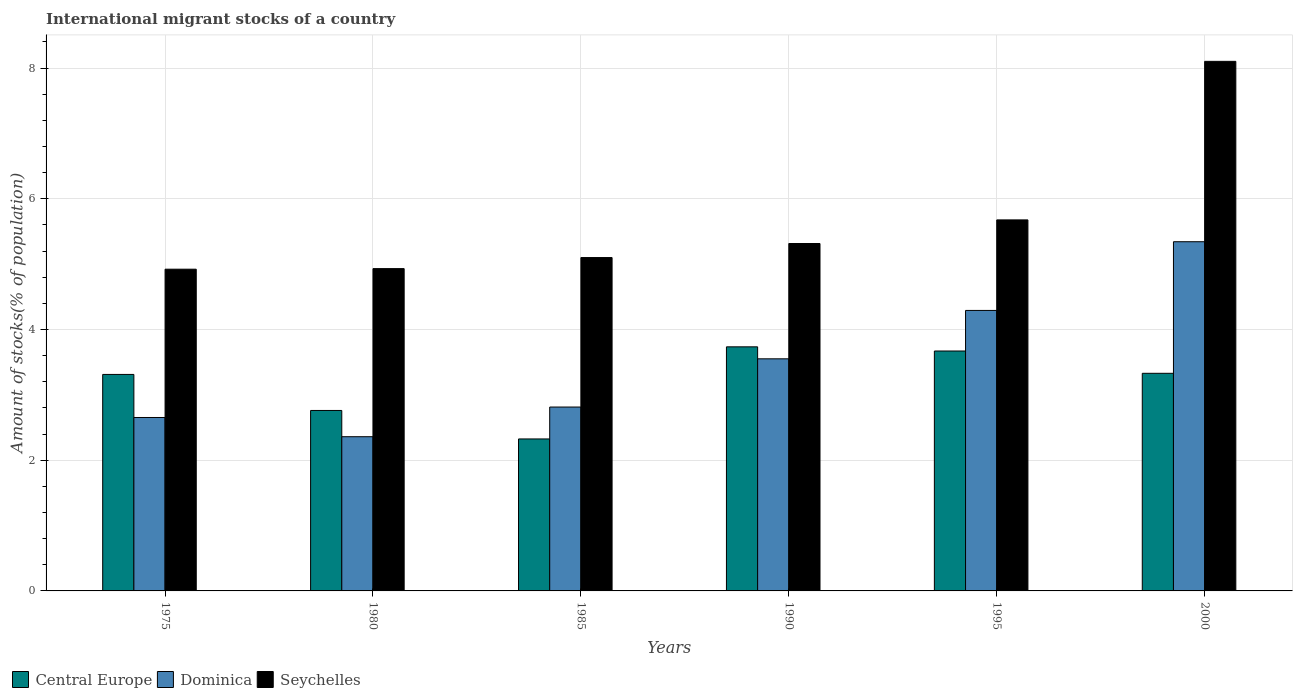Are the number of bars per tick equal to the number of legend labels?
Ensure brevity in your answer.  Yes. Are the number of bars on each tick of the X-axis equal?
Your response must be concise. Yes. How many bars are there on the 5th tick from the left?
Offer a terse response. 3. What is the label of the 4th group of bars from the left?
Provide a short and direct response. 1990. What is the amount of stocks in in Central Europe in 1995?
Your response must be concise. 3.67. Across all years, what is the maximum amount of stocks in in Seychelles?
Your answer should be very brief. 8.1. Across all years, what is the minimum amount of stocks in in Central Europe?
Your response must be concise. 2.33. In which year was the amount of stocks in in Seychelles maximum?
Make the answer very short. 2000. What is the total amount of stocks in in Seychelles in the graph?
Your answer should be compact. 34.05. What is the difference between the amount of stocks in in Dominica in 1985 and that in 1995?
Your answer should be compact. -1.48. What is the difference between the amount of stocks in in Central Europe in 2000 and the amount of stocks in in Dominica in 1980?
Provide a short and direct response. 0.97. What is the average amount of stocks in in Central Europe per year?
Provide a succinct answer. 3.19. In the year 1980, what is the difference between the amount of stocks in in Central Europe and amount of stocks in in Dominica?
Keep it short and to the point. 0.4. In how many years, is the amount of stocks in in Dominica greater than 7.2 %?
Provide a succinct answer. 0. What is the ratio of the amount of stocks in in Dominica in 1995 to that in 2000?
Ensure brevity in your answer.  0.8. Is the amount of stocks in in Seychelles in 1975 less than that in 1985?
Offer a very short reply. Yes. Is the difference between the amount of stocks in in Central Europe in 1995 and 2000 greater than the difference between the amount of stocks in in Dominica in 1995 and 2000?
Make the answer very short. Yes. What is the difference between the highest and the second highest amount of stocks in in Central Europe?
Your answer should be very brief. 0.06. What is the difference between the highest and the lowest amount of stocks in in Dominica?
Your answer should be very brief. 2.98. In how many years, is the amount of stocks in in Dominica greater than the average amount of stocks in in Dominica taken over all years?
Keep it short and to the point. 3. What does the 3rd bar from the left in 1995 represents?
Make the answer very short. Seychelles. What does the 3rd bar from the right in 1980 represents?
Keep it short and to the point. Central Europe. Are all the bars in the graph horizontal?
Keep it short and to the point. No. What is the difference between two consecutive major ticks on the Y-axis?
Your answer should be very brief. 2. What is the title of the graph?
Offer a terse response. International migrant stocks of a country. What is the label or title of the Y-axis?
Offer a terse response. Amount of stocks(% of population). What is the Amount of stocks(% of population) in Central Europe in 1975?
Your response must be concise. 3.31. What is the Amount of stocks(% of population) of Dominica in 1975?
Offer a terse response. 2.65. What is the Amount of stocks(% of population) in Seychelles in 1975?
Your answer should be very brief. 4.92. What is the Amount of stocks(% of population) in Central Europe in 1980?
Offer a very short reply. 2.76. What is the Amount of stocks(% of population) of Dominica in 1980?
Give a very brief answer. 2.36. What is the Amount of stocks(% of population) in Seychelles in 1980?
Offer a very short reply. 4.93. What is the Amount of stocks(% of population) in Central Europe in 1985?
Offer a terse response. 2.33. What is the Amount of stocks(% of population) in Dominica in 1985?
Make the answer very short. 2.81. What is the Amount of stocks(% of population) in Seychelles in 1985?
Offer a very short reply. 5.1. What is the Amount of stocks(% of population) of Central Europe in 1990?
Make the answer very short. 3.73. What is the Amount of stocks(% of population) of Dominica in 1990?
Offer a terse response. 3.55. What is the Amount of stocks(% of population) in Seychelles in 1990?
Offer a terse response. 5.32. What is the Amount of stocks(% of population) of Central Europe in 1995?
Offer a very short reply. 3.67. What is the Amount of stocks(% of population) in Dominica in 1995?
Make the answer very short. 4.29. What is the Amount of stocks(% of population) in Seychelles in 1995?
Offer a terse response. 5.68. What is the Amount of stocks(% of population) in Central Europe in 2000?
Ensure brevity in your answer.  3.33. What is the Amount of stocks(% of population) in Dominica in 2000?
Make the answer very short. 5.34. What is the Amount of stocks(% of population) in Seychelles in 2000?
Ensure brevity in your answer.  8.1. Across all years, what is the maximum Amount of stocks(% of population) of Central Europe?
Your response must be concise. 3.73. Across all years, what is the maximum Amount of stocks(% of population) of Dominica?
Provide a short and direct response. 5.34. Across all years, what is the maximum Amount of stocks(% of population) of Seychelles?
Provide a succinct answer. 8.1. Across all years, what is the minimum Amount of stocks(% of population) in Central Europe?
Your answer should be very brief. 2.33. Across all years, what is the minimum Amount of stocks(% of population) of Dominica?
Keep it short and to the point. 2.36. Across all years, what is the minimum Amount of stocks(% of population) of Seychelles?
Offer a very short reply. 4.92. What is the total Amount of stocks(% of population) of Central Europe in the graph?
Keep it short and to the point. 19.13. What is the total Amount of stocks(% of population) of Dominica in the graph?
Provide a short and direct response. 21.01. What is the total Amount of stocks(% of population) of Seychelles in the graph?
Offer a terse response. 34.05. What is the difference between the Amount of stocks(% of population) in Central Europe in 1975 and that in 1980?
Provide a succinct answer. 0.55. What is the difference between the Amount of stocks(% of population) of Dominica in 1975 and that in 1980?
Ensure brevity in your answer.  0.29. What is the difference between the Amount of stocks(% of population) in Seychelles in 1975 and that in 1980?
Give a very brief answer. -0.01. What is the difference between the Amount of stocks(% of population) of Central Europe in 1975 and that in 1985?
Provide a short and direct response. 0.99. What is the difference between the Amount of stocks(% of population) of Dominica in 1975 and that in 1985?
Offer a very short reply. -0.16. What is the difference between the Amount of stocks(% of population) in Seychelles in 1975 and that in 1985?
Ensure brevity in your answer.  -0.18. What is the difference between the Amount of stocks(% of population) in Central Europe in 1975 and that in 1990?
Keep it short and to the point. -0.42. What is the difference between the Amount of stocks(% of population) of Dominica in 1975 and that in 1990?
Ensure brevity in your answer.  -0.9. What is the difference between the Amount of stocks(% of population) in Seychelles in 1975 and that in 1990?
Provide a short and direct response. -0.39. What is the difference between the Amount of stocks(% of population) of Central Europe in 1975 and that in 1995?
Offer a very short reply. -0.36. What is the difference between the Amount of stocks(% of population) in Dominica in 1975 and that in 1995?
Keep it short and to the point. -1.64. What is the difference between the Amount of stocks(% of population) in Seychelles in 1975 and that in 1995?
Your answer should be compact. -0.75. What is the difference between the Amount of stocks(% of population) of Central Europe in 1975 and that in 2000?
Give a very brief answer. -0.02. What is the difference between the Amount of stocks(% of population) in Dominica in 1975 and that in 2000?
Your response must be concise. -2.69. What is the difference between the Amount of stocks(% of population) in Seychelles in 1975 and that in 2000?
Give a very brief answer. -3.18. What is the difference between the Amount of stocks(% of population) in Central Europe in 1980 and that in 1985?
Provide a succinct answer. 0.44. What is the difference between the Amount of stocks(% of population) of Dominica in 1980 and that in 1985?
Offer a terse response. -0.45. What is the difference between the Amount of stocks(% of population) of Seychelles in 1980 and that in 1985?
Keep it short and to the point. -0.17. What is the difference between the Amount of stocks(% of population) in Central Europe in 1980 and that in 1990?
Ensure brevity in your answer.  -0.97. What is the difference between the Amount of stocks(% of population) in Dominica in 1980 and that in 1990?
Ensure brevity in your answer.  -1.19. What is the difference between the Amount of stocks(% of population) in Seychelles in 1980 and that in 1990?
Make the answer very short. -0.38. What is the difference between the Amount of stocks(% of population) in Central Europe in 1980 and that in 1995?
Make the answer very short. -0.91. What is the difference between the Amount of stocks(% of population) in Dominica in 1980 and that in 1995?
Provide a succinct answer. -1.93. What is the difference between the Amount of stocks(% of population) in Seychelles in 1980 and that in 1995?
Offer a very short reply. -0.75. What is the difference between the Amount of stocks(% of population) in Central Europe in 1980 and that in 2000?
Keep it short and to the point. -0.57. What is the difference between the Amount of stocks(% of population) in Dominica in 1980 and that in 2000?
Provide a succinct answer. -2.98. What is the difference between the Amount of stocks(% of population) of Seychelles in 1980 and that in 2000?
Provide a short and direct response. -3.17. What is the difference between the Amount of stocks(% of population) in Central Europe in 1985 and that in 1990?
Provide a succinct answer. -1.41. What is the difference between the Amount of stocks(% of population) of Dominica in 1985 and that in 1990?
Keep it short and to the point. -0.74. What is the difference between the Amount of stocks(% of population) in Seychelles in 1985 and that in 1990?
Your answer should be very brief. -0.21. What is the difference between the Amount of stocks(% of population) in Central Europe in 1985 and that in 1995?
Your answer should be compact. -1.35. What is the difference between the Amount of stocks(% of population) in Dominica in 1985 and that in 1995?
Provide a succinct answer. -1.48. What is the difference between the Amount of stocks(% of population) in Seychelles in 1985 and that in 1995?
Make the answer very short. -0.58. What is the difference between the Amount of stocks(% of population) in Central Europe in 1985 and that in 2000?
Make the answer very short. -1. What is the difference between the Amount of stocks(% of population) in Dominica in 1985 and that in 2000?
Keep it short and to the point. -2.53. What is the difference between the Amount of stocks(% of population) of Seychelles in 1985 and that in 2000?
Keep it short and to the point. -3. What is the difference between the Amount of stocks(% of population) in Central Europe in 1990 and that in 1995?
Give a very brief answer. 0.06. What is the difference between the Amount of stocks(% of population) in Dominica in 1990 and that in 1995?
Offer a very short reply. -0.74. What is the difference between the Amount of stocks(% of population) in Seychelles in 1990 and that in 1995?
Your answer should be compact. -0.36. What is the difference between the Amount of stocks(% of population) of Central Europe in 1990 and that in 2000?
Your response must be concise. 0.41. What is the difference between the Amount of stocks(% of population) in Dominica in 1990 and that in 2000?
Ensure brevity in your answer.  -1.79. What is the difference between the Amount of stocks(% of population) in Seychelles in 1990 and that in 2000?
Give a very brief answer. -2.79. What is the difference between the Amount of stocks(% of population) in Central Europe in 1995 and that in 2000?
Offer a very short reply. 0.34. What is the difference between the Amount of stocks(% of population) of Dominica in 1995 and that in 2000?
Ensure brevity in your answer.  -1.05. What is the difference between the Amount of stocks(% of population) of Seychelles in 1995 and that in 2000?
Provide a succinct answer. -2.43. What is the difference between the Amount of stocks(% of population) in Central Europe in 1975 and the Amount of stocks(% of population) in Dominica in 1980?
Ensure brevity in your answer.  0.95. What is the difference between the Amount of stocks(% of population) of Central Europe in 1975 and the Amount of stocks(% of population) of Seychelles in 1980?
Make the answer very short. -1.62. What is the difference between the Amount of stocks(% of population) in Dominica in 1975 and the Amount of stocks(% of population) in Seychelles in 1980?
Ensure brevity in your answer.  -2.28. What is the difference between the Amount of stocks(% of population) in Central Europe in 1975 and the Amount of stocks(% of population) in Dominica in 1985?
Offer a terse response. 0.5. What is the difference between the Amount of stocks(% of population) in Central Europe in 1975 and the Amount of stocks(% of population) in Seychelles in 1985?
Offer a terse response. -1.79. What is the difference between the Amount of stocks(% of population) of Dominica in 1975 and the Amount of stocks(% of population) of Seychelles in 1985?
Give a very brief answer. -2.45. What is the difference between the Amount of stocks(% of population) of Central Europe in 1975 and the Amount of stocks(% of population) of Dominica in 1990?
Offer a terse response. -0.24. What is the difference between the Amount of stocks(% of population) in Central Europe in 1975 and the Amount of stocks(% of population) in Seychelles in 1990?
Provide a short and direct response. -2. What is the difference between the Amount of stocks(% of population) in Dominica in 1975 and the Amount of stocks(% of population) in Seychelles in 1990?
Your answer should be compact. -2.66. What is the difference between the Amount of stocks(% of population) in Central Europe in 1975 and the Amount of stocks(% of population) in Dominica in 1995?
Offer a very short reply. -0.98. What is the difference between the Amount of stocks(% of population) of Central Europe in 1975 and the Amount of stocks(% of population) of Seychelles in 1995?
Provide a succinct answer. -2.36. What is the difference between the Amount of stocks(% of population) in Dominica in 1975 and the Amount of stocks(% of population) in Seychelles in 1995?
Your answer should be very brief. -3.02. What is the difference between the Amount of stocks(% of population) of Central Europe in 1975 and the Amount of stocks(% of population) of Dominica in 2000?
Give a very brief answer. -2.03. What is the difference between the Amount of stocks(% of population) of Central Europe in 1975 and the Amount of stocks(% of population) of Seychelles in 2000?
Ensure brevity in your answer.  -4.79. What is the difference between the Amount of stocks(% of population) in Dominica in 1975 and the Amount of stocks(% of population) in Seychelles in 2000?
Offer a very short reply. -5.45. What is the difference between the Amount of stocks(% of population) in Central Europe in 1980 and the Amount of stocks(% of population) in Dominica in 1985?
Provide a succinct answer. -0.05. What is the difference between the Amount of stocks(% of population) in Central Europe in 1980 and the Amount of stocks(% of population) in Seychelles in 1985?
Keep it short and to the point. -2.34. What is the difference between the Amount of stocks(% of population) of Dominica in 1980 and the Amount of stocks(% of population) of Seychelles in 1985?
Provide a short and direct response. -2.74. What is the difference between the Amount of stocks(% of population) in Central Europe in 1980 and the Amount of stocks(% of population) in Dominica in 1990?
Offer a very short reply. -0.79. What is the difference between the Amount of stocks(% of population) in Central Europe in 1980 and the Amount of stocks(% of population) in Seychelles in 1990?
Make the answer very short. -2.55. What is the difference between the Amount of stocks(% of population) of Dominica in 1980 and the Amount of stocks(% of population) of Seychelles in 1990?
Make the answer very short. -2.96. What is the difference between the Amount of stocks(% of population) in Central Europe in 1980 and the Amount of stocks(% of population) in Dominica in 1995?
Your response must be concise. -1.53. What is the difference between the Amount of stocks(% of population) in Central Europe in 1980 and the Amount of stocks(% of population) in Seychelles in 1995?
Provide a succinct answer. -2.92. What is the difference between the Amount of stocks(% of population) in Dominica in 1980 and the Amount of stocks(% of population) in Seychelles in 1995?
Make the answer very short. -3.32. What is the difference between the Amount of stocks(% of population) in Central Europe in 1980 and the Amount of stocks(% of population) in Dominica in 2000?
Offer a terse response. -2.58. What is the difference between the Amount of stocks(% of population) in Central Europe in 1980 and the Amount of stocks(% of population) in Seychelles in 2000?
Keep it short and to the point. -5.34. What is the difference between the Amount of stocks(% of population) in Dominica in 1980 and the Amount of stocks(% of population) in Seychelles in 2000?
Provide a short and direct response. -5.74. What is the difference between the Amount of stocks(% of population) in Central Europe in 1985 and the Amount of stocks(% of population) in Dominica in 1990?
Provide a short and direct response. -1.23. What is the difference between the Amount of stocks(% of population) in Central Europe in 1985 and the Amount of stocks(% of population) in Seychelles in 1990?
Ensure brevity in your answer.  -2.99. What is the difference between the Amount of stocks(% of population) of Dominica in 1985 and the Amount of stocks(% of population) of Seychelles in 1990?
Your answer should be very brief. -2.5. What is the difference between the Amount of stocks(% of population) of Central Europe in 1985 and the Amount of stocks(% of population) of Dominica in 1995?
Provide a succinct answer. -1.97. What is the difference between the Amount of stocks(% of population) of Central Europe in 1985 and the Amount of stocks(% of population) of Seychelles in 1995?
Give a very brief answer. -3.35. What is the difference between the Amount of stocks(% of population) in Dominica in 1985 and the Amount of stocks(% of population) in Seychelles in 1995?
Your response must be concise. -2.86. What is the difference between the Amount of stocks(% of population) of Central Europe in 1985 and the Amount of stocks(% of population) of Dominica in 2000?
Provide a succinct answer. -3.02. What is the difference between the Amount of stocks(% of population) of Central Europe in 1985 and the Amount of stocks(% of population) of Seychelles in 2000?
Your answer should be compact. -5.78. What is the difference between the Amount of stocks(% of population) in Dominica in 1985 and the Amount of stocks(% of population) in Seychelles in 2000?
Make the answer very short. -5.29. What is the difference between the Amount of stocks(% of population) of Central Europe in 1990 and the Amount of stocks(% of population) of Dominica in 1995?
Offer a terse response. -0.56. What is the difference between the Amount of stocks(% of population) of Central Europe in 1990 and the Amount of stocks(% of population) of Seychelles in 1995?
Your answer should be very brief. -1.94. What is the difference between the Amount of stocks(% of population) in Dominica in 1990 and the Amount of stocks(% of population) in Seychelles in 1995?
Make the answer very short. -2.13. What is the difference between the Amount of stocks(% of population) in Central Europe in 1990 and the Amount of stocks(% of population) in Dominica in 2000?
Make the answer very short. -1.61. What is the difference between the Amount of stocks(% of population) of Central Europe in 1990 and the Amount of stocks(% of population) of Seychelles in 2000?
Give a very brief answer. -4.37. What is the difference between the Amount of stocks(% of population) of Dominica in 1990 and the Amount of stocks(% of population) of Seychelles in 2000?
Keep it short and to the point. -4.55. What is the difference between the Amount of stocks(% of population) in Central Europe in 1995 and the Amount of stocks(% of population) in Dominica in 2000?
Provide a succinct answer. -1.67. What is the difference between the Amount of stocks(% of population) of Central Europe in 1995 and the Amount of stocks(% of population) of Seychelles in 2000?
Provide a succinct answer. -4.43. What is the difference between the Amount of stocks(% of population) in Dominica in 1995 and the Amount of stocks(% of population) in Seychelles in 2000?
Give a very brief answer. -3.81. What is the average Amount of stocks(% of population) of Central Europe per year?
Ensure brevity in your answer.  3.19. What is the average Amount of stocks(% of population) of Dominica per year?
Give a very brief answer. 3.5. What is the average Amount of stocks(% of population) of Seychelles per year?
Provide a succinct answer. 5.68. In the year 1975, what is the difference between the Amount of stocks(% of population) in Central Europe and Amount of stocks(% of population) in Dominica?
Offer a terse response. 0.66. In the year 1975, what is the difference between the Amount of stocks(% of population) in Central Europe and Amount of stocks(% of population) in Seychelles?
Provide a short and direct response. -1.61. In the year 1975, what is the difference between the Amount of stocks(% of population) of Dominica and Amount of stocks(% of population) of Seychelles?
Give a very brief answer. -2.27. In the year 1980, what is the difference between the Amount of stocks(% of population) in Central Europe and Amount of stocks(% of population) in Dominica?
Your response must be concise. 0.4. In the year 1980, what is the difference between the Amount of stocks(% of population) of Central Europe and Amount of stocks(% of population) of Seychelles?
Provide a succinct answer. -2.17. In the year 1980, what is the difference between the Amount of stocks(% of population) in Dominica and Amount of stocks(% of population) in Seychelles?
Offer a very short reply. -2.57. In the year 1985, what is the difference between the Amount of stocks(% of population) in Central Europe and Amount of stocks(% of population) in Dominica?
Give a very brief answer. -0.49. In the year 1985, what is the difference between the Amount of stocks(% of population) of Central Europe and Amount of stocks(% of population) of Seychelles?
Offer a terse response. -2.78. In the year 1985, what is the difference between the Amount of stocks(% of population) of Dominica and Amount of stocks(% of population) of Seychelles?
Your answer should be very brief. -2.29. In the year 1990, what is the difference between the Amount of stocks(% of population) of Central Europe and Amount of stocks(% of population) of Dominica?
Your answer should be very brief. 0.18. In the year 1990, what is the difference between the Amount of stocks(% of population) of Central Europe and Amount of stocks(% of population) of Seychelles?
Make the answer very short. -1.58. In the year 1990, what is the difference between the Amount of stocks(% of population) of Dominica and Amount of stocks(% of population) of Seychelles?
Make the answer very short. -1.76. In the year 1995, what is the difference between the Amount of stocks(% of population) in Central Europe and Amount of stocks(% of population) in Dominica?
Your answer should be compact. -0.62. In the year 1995, what is the difference between the Amount of stocks(% of population) of Central Europe and Amount of stocks(% of population) of Seychelles?
Your answer should be compact. -2.01. In the year 1995, what is the difference between the Amount of stocks(% of population) of Dominica and Amount of stocks(% of population) of Seychelles?
Your answer should be very brief. -1.39. In the year 2000, what is the difference between the Amount of stocks(% of population) of Central Europe and Amount of stocks(% of population) of Dominica?
Provide a succinct answer. -2.01. In the year 2000, what is the difference between the Amount of stocks(% of population) in Central Europe and Amount of stocks(% of population) in Seychelles?
Provide a short and direct response. -4.77. In the year 2000, what is the difference between the Amount of stocks(% of population) in Dominica and Amount of stocks(% of population) in Seychelles?
Your response must be concise. -2.76. What is the ratio of the Amount of stocks(% of population) of Central Europe in 1975 to that in 1980?
Ensure brevity in your answer.  1.2. What is the ratio of the Amount of stocks(% of population) of Dominica in 1975 to that in 1980?
Give a very brief answer. 1.12. What is the ratio of the Amount of stocks(% of population) in Seychelles in 1975 to that in 1980?
Your answer should be compact. 1. What is the ratio of the Amount of stocks(% of population) in Central Europe in 1975 to that in 1985?
Offer a terse response. 1.42. What is the ratio of the Amount of stocks(% of population) of Dominica in 1975 to that in 1985?
Give a very brief answer. 0.94. What is the ratio of the Amount of stocks(% of population) in Seychelles in 1975 to that in 1985?
Provide a short and direct response. 0.97. What is the ratio of the Amount of stocks(% of population) of Central Europe in 1975 to that in 1990?
Give a very brief answer. 0.89. What is the ratio of the Amount of stocks(% of population) of Dominica in 1975 to that in 1990?
Provide a short and direct response. 0.75. What is the ratio of the Amount of stocks(% of population) of Seychelles in 1975 to that in 1990?
Offer a very short reply. 0.93. What is the ratio of the Amount of stocks(% of population) of Central Europe in 1975 to that in 1995?
Your response must be concise. 0.9. What is the ratio of the Amount of stocks(% of population) in Dominica in 1975 to that in 1995?
Your answer should be very brief. 0.62. What is the ratio of the Amount of stocks(% of population) of Seychelles in 1975 to that in 1995?
Your answer should be very brief. 0.87. What is the ratio of the Amount of stocks(% of population) of Dominica in 1975 to that in 2000?
Your answer should be very brief. 0.5. What is the ratio of the Amount of stocks(% of population) of Seychelles in 1975 to that in 2000?
Your answer should be very brief. 0.61. What is the ratio of the Amount of stocks(% of population) in Central Europe in 1980 to that in 1985?
Offer a terse response. 1.19. What is the ratio of the Amount of stocks(% of population) of Dominica in 1980 to that in 1985?
Offer a terse response. 0.84. What is the ratio of the Amount of stocks(% of population) of Seychelles in 1980 to that in 1985?
Offer a very short reply. 0.97. What is the ratio of the Amount of stocks(% of population) in Central Europe in 1980 to that in 1990?
Make the answer very short. 0.74. What is the ratio of the Amount of stocks(% of population) in Dominica in 1980 to that in 1990?
Offer a terse response. 0.66. What is the ratio of the Amount of stocks(% of population) of Seychelles in 1980 to that in 1990?
Provide a short and direct response. 0.93. What is the ratio of the Amount of stocks(% of population) of Central Europe in 1980 to that in 1995?
Provide a short and direct response. 0.75. What is the ratio of the Amount of stocks(% of population) of Dominica in 1980 to that in 1995?
Your answer should be very brief. 0.55. What is the ratio of the Amount of stocks(% of population) in Seychelles in 1980 to that in 1995?
Your answer should be compact. 0.87. What is the ratio of the Amount of stocks(% of population) of Central Europe in 1980 to that in 2000?
Make the answer very short. 0.83. What is the ratio of the Amount of stocks(% of population) in Dominica in 1980 to that in 2000?
Provide a short and direct response. 0.44. What is the ratio of the Amount of stocks(% of population) of Seychelles in 1980 to that in 2000?
Offer a terse response. 0.61. What is the ratio of the Amount of stocks(% of population) of Central Europe in 1985 to that in 1990?
Your answer should be very brief. 0.62. What is the ratio of the Amount of stocks(% of population) in Dominica in 1985 to that in 1990?
Offer a terse response. 0.79. What is the ratio of the Amount of stocks(% of population) of Seychelles in 1985 to that in 1990?
Offer a terse response. 0.96. What is the ratio of the Amount of stocks(% of population) of Central Europe in 1985 to that in 1995?
Your answer should be compact. 0.63. What is the ratio of the Amount of stocks(% of population) in Dominica in 1985 to that in 1995?
Your answer should be compact. 0.66. What is the ratio of the Amount of stocks(% of population) of Seychelles in 1985 to that in 1995?
Offer a terse response. 0.9. What is the ratio of the Amount of stocks(% of population) in Central Europe in 1985 to that in 2000?
Ensure brevity in your answer.  0.7. What is the ratio of the Amount of stocks(% of population) in Dominica in 1985 to that in 2000?
Offer a very short reply. 0.53. What is the ratio of the Amount of stocks(% of population) of Seychelles in 1985 to that in 2000?
Your response must be concise. 0.63. What is the ratio of the Amount of stocks(% of population) of Central Europe in 1990 to that in 1995?
Provide a short and direct response. 1.02. What is the ratio of the Amount of stocks(% of population) in Dominica in 1990 to that in 1995?
Give a very brief answer. 0.83. What is the ratio of the Amount of stocks(% of population) of Seychelles in 1990 to that in 1995?
Your answer should be very brief. 0.94. What is the ratio of the Amount of stocks(% of population) in Central Europe in 1990 to that in 2000?
Give a very brief answer. 1.12. What is the ratio of the Amount of stocks(% of population) in Dominica in 1990 to that in 2000?
Provide a short and direct response. 0.66. What is the ratio of the Amount of stocks(% of population) in Seychelles in 1990 to that in 2000?
Provide a short and direct response. 0.66. What is the ratio of the Amount of stocks(% of population) in Central Europe in 1995 to that in 2000?
Your answer should be very brief. 1.1. What is the ratio of the Amount of stocks(% of population) of Dominica in 1995 to that in 2000?
Offer a terse response. 0.8. What is the ratio of the Amount of stocks(% of population) of Seychelles in 1995 to that in 2000?
Ensure brevity in your answer.  0.7. What is the difference between the highest and the second highest Amount of stocks(% of population) of Central Europe?
Offer a terse response. 0.06. What is the difference between the highest and the second highest Amount of stocks(% of population) of Dominica?
Offer a terse response. 1.05. What is the difference between the highest and the second highest Amount of stocks(% of population) in Seychelles?
Your answer should be compact. 2.43. What is the difference between the highest and the lowest Amount of stocks(% of population) of Central Europe?
Provide a succinct answer. 1.41. What is the difference between the highest and the lowest Amount of stocks(% of population) of Dominica?
Offer a terse response. 2.98. What is the difference between the highest and the lowest Amount of stocks(% of population) of Seychelles?
Provide a succinct answer. 3.18. 